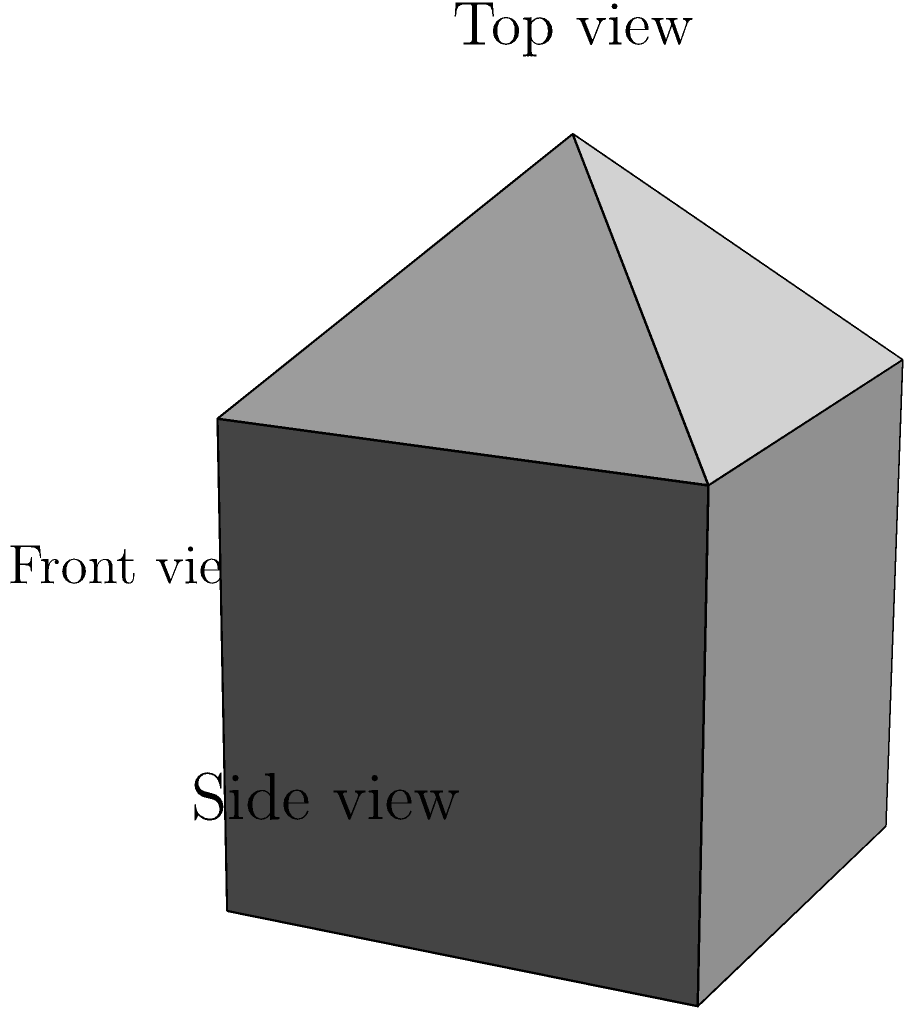Given the 3D-printed object shown above, which of the following statements is true about its orientation when viewed from different angles?

A) The protrusion is visible in the front view and side view, but not in the top view.
B) The protrusion is visible in the top view and side view, but not in the front view.
C) The protrusion is visible in all three views: front, top, and side.
D) The protrusion is only visible in the top view. Let's analyze the object's orientation step by step:

1. Front view:
   - This view looks at the object from the front (along the y-axis).
   - The protrusion is not visible as it is centered on the top face.

2. Top view:
   - This view looks at the object from above (along the z-axis).
   - The protrusion is clearly visible as a point or small circle in the center of the square top face.

3. Side view:
   - This view looks at the object from the side (along the x-axis).
   - The protrusion is visible as it extends upward from the top face.

4. Analyzing the options:
   A) Incorrect: The protrusion is not visible in the front view.
   B) Correct: The protrusion is visible in both the top and side views, but not in the front view.
   C) Incorrect: The protrusion is not visible in all three views.
   D) Incorrect: The protrusion is visible in more than just the top view.

Therefore, the correct statement is option B.
Answer: B 